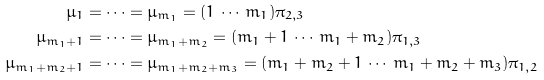<formula> <loc_0><loc_0><loc_500><loc_500>\mu _ { 1 } & = \dots = \mu _ { m _ { 1 } } = ( 1 \, \cdots \, m _ { 1 } ) \pi _ { 2 , 3 } \\ \mu _ { m _ { 1 } + 1 } & = \dots = \mu _ { m _ { 1 } + m _ { 2 } } = ( m _ { 1 } + 1 \, \cdots \, m _ { 1 } + m _ { 2 } ) \pi _ { 1 , 3 } \\ \mu _ { m _ { 1 } + m _ { 2 } + 1 } & = \dots = \mu _ { m _ { 1 } + m _ { 2 } + m _ { 3 } } = ( m _ { 1 } + m _ { 2 } + 1 \, \cdots \, m _ { 1 } + m _ { 2 } + m _ { 3 } ) \pi _ { 1 , 2 }</formula> 